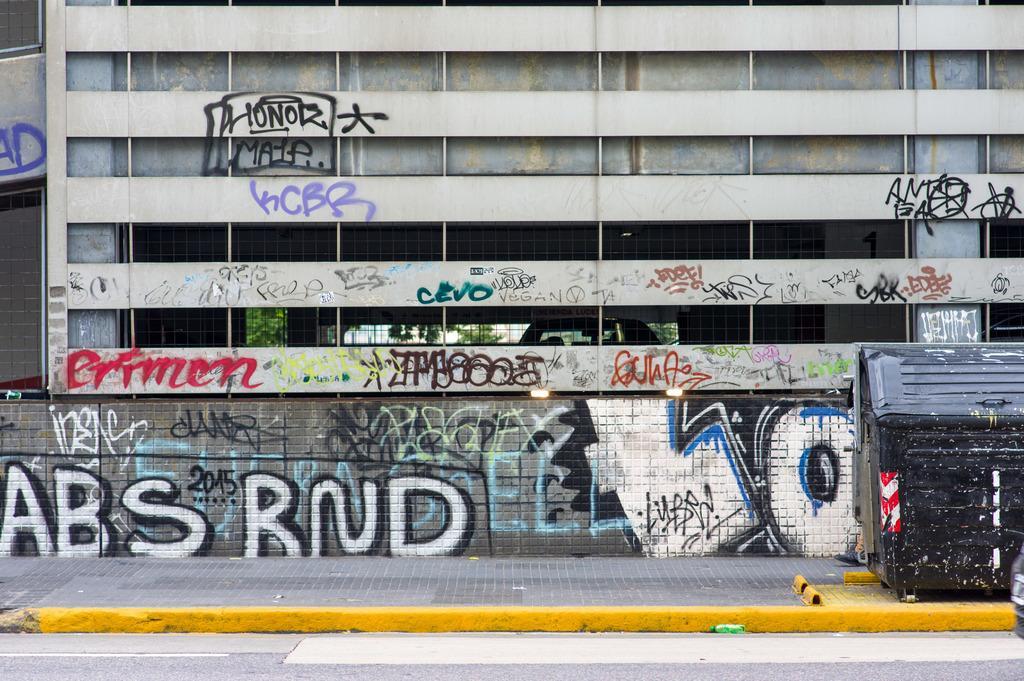In one or two sentences, can you explain what this image depicts? In this image we can see a building with text on the walls and there is a fence to the building, there is a car inside the building, there are trees in the background and in front of the building there is a black color object on the pavement and there is a road beside the pavement. 